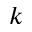Convert formula to latex. <formula><loc_0><loc_0><loc_500><loc_500>k</formula> 